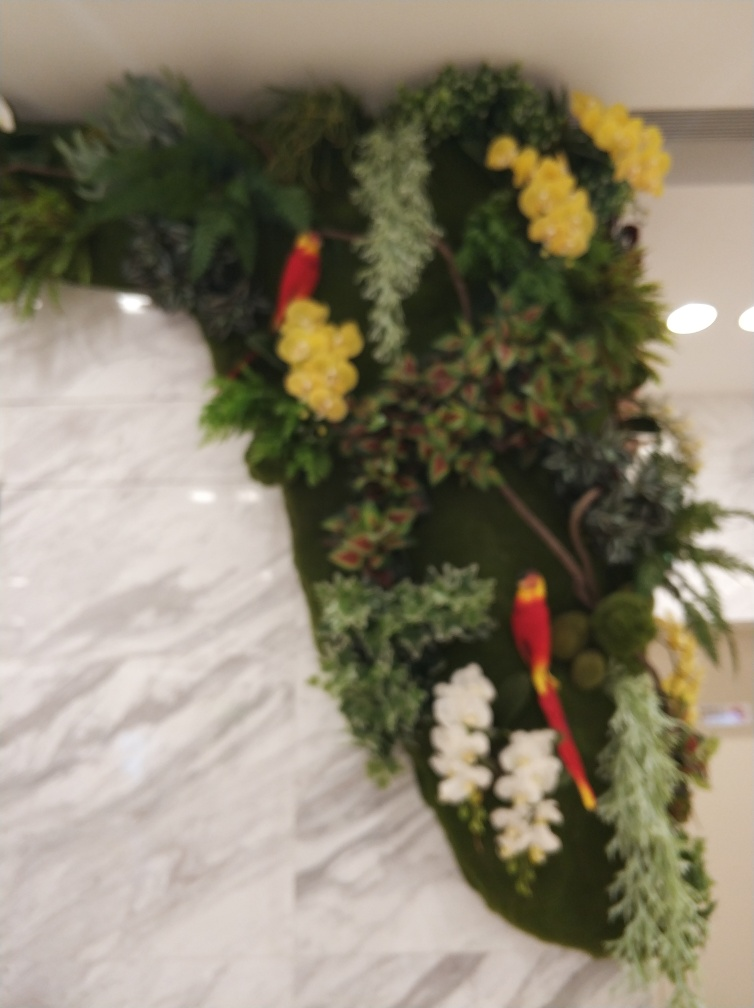What is the condition of the main subject, the bird?
A. perfect and well-defined
B. clear and sharp
C. lost most of its texture details and slightly blurry
Answer with the option's letter from the given choices directly.
 C. 